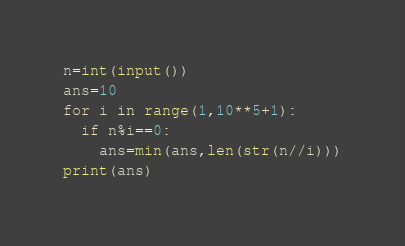Convert code to text. <code><loc_0><loc_0><loc_500><loc_500><_Python_>n=int(input())
ans=10
for i in range(1,10**5+1):
  if n%i==0:
    ans=min(ans,len(str(n//i)))
print(ans)</code> 